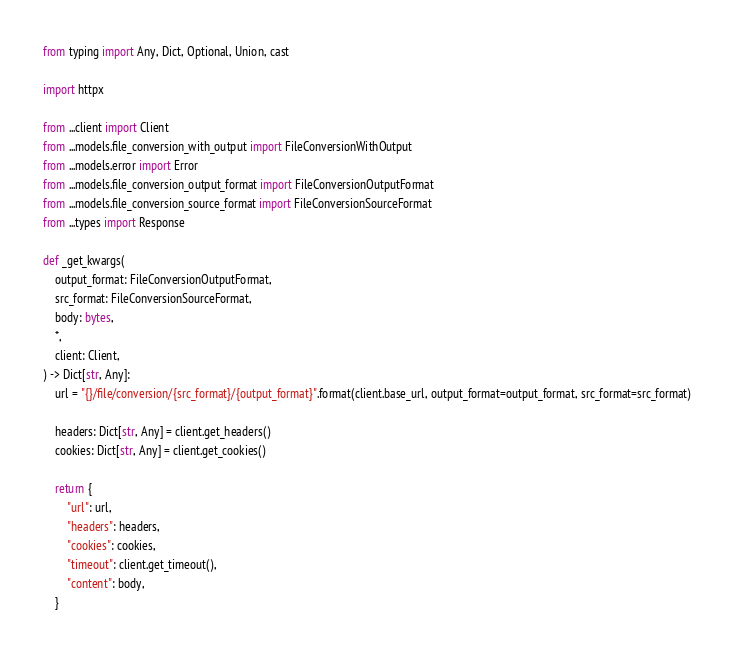Convert code to text. <code><loc_0><loc_0><loc_500><loc_500><_Python_>from typing import Any, Dict, Optional, Union, cast

import httpx

from ...client import Client
from ...models.file_conversion_with_output import FileConversionWithOutput
from ...models.error import Error
from ...models.file_conversion_output_format import FileConversionOutputFormat
from ...models.file_conversion_source_format import FileConversionSourceFormat
from ...types import Response

def _get_kwargs(
	output_format: FileConversionOutputFormat,
	src_format: FileConversionSourceFormat,
	body: bytes,
	*,
	client: Client,
) -> Dict[str, Any]:
	url = "{}/file/conversion/{src_format}/{output_format}".format(client.base_url, output_format=output_format, src_format=src_format)

	headers: Dict[str, Any] = client.get_headers()
	cookies: Dict[str, Any] = client.get_cookies()

	return {
		"url": url,
		"headers": headers,
		"cookies": cookies,
		"timeout": client.get_timeout(),
		"content": body,
	}

</code> 